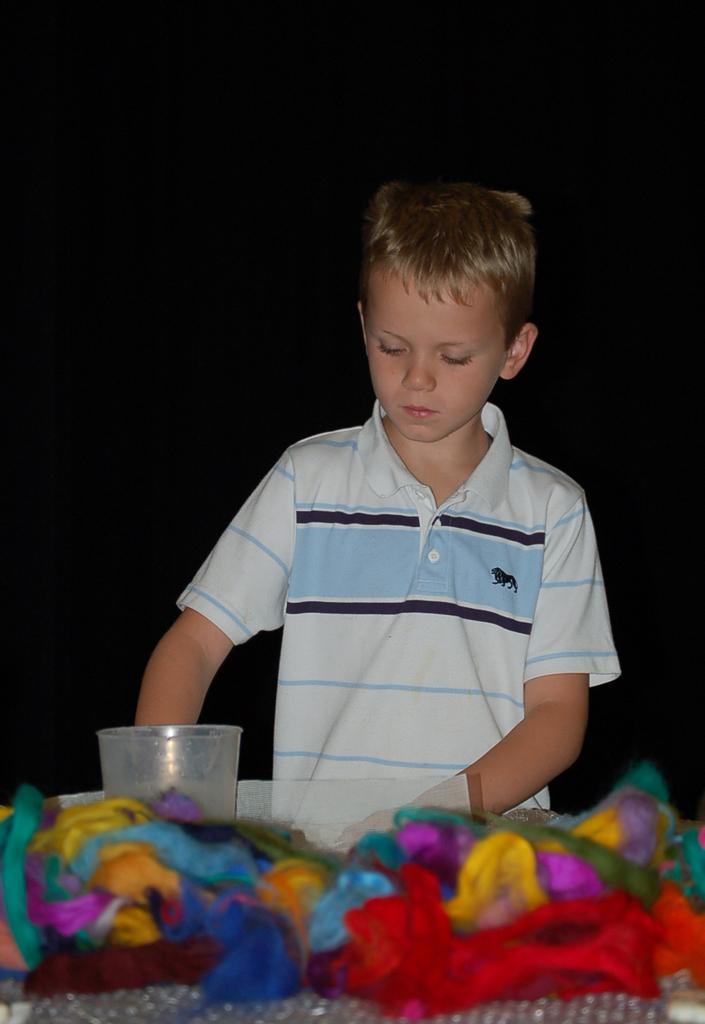Could you give a brief overview of what you see in this image? In this image, we can see a boy. At the bottom of the image, we can see colorful objects and glass. In the background, we can see dark. 